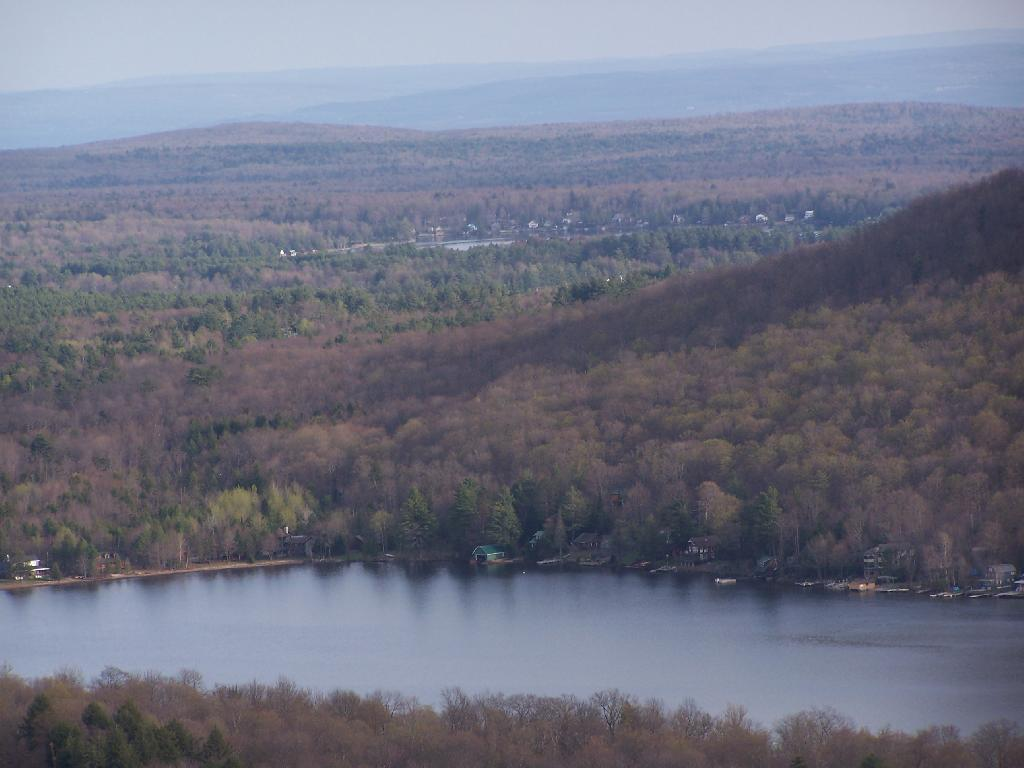What type of natural vegetation can be seen in the image? There are trees in the image. What body of water is visible in the image? There is water visible in the image. What structures are located near the water? There are sheds beside the water. What objects can be found near the sheds? There are objects near the sheds. What type of landscape can be seen in the background of the image? There are mountains in the background of the image. What else is visible in the background of the image? The sky is visible in the background of the image. What time does the clock on the tramp indicate in the image? There is no clock or tramp present in the image. What type of work is being done near the sheds in the image? There is no indication of any work being done in the image; it simply shows sheds, objects, and the surrounding environment. 